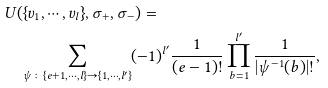<formula> <loc_0><loc_0><loc_500><loc_500>& U ( \{ v _ { 1 } , \cdots , v _ { l } \} , \sigma _ { + } , \sigma _ { - } ) = \\ & \quad \sum _ { \psi \colon \{ e + 1 , \cdots , l \} \to \{ 1 , \cdots , l ^ { \prime } \} } ( - 1 ) ^ { l ^ { \prime } } \frac { 1 } { ( e - 1 ) ! } \prod _ { b = 1 } ^ { l ^ { \prime } } \frac { 1 } { | \psi ^ { - 1 } ( b ) | ! } ,</formula> 